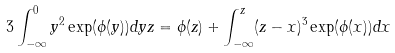Convert formula to latex. <formula><loc_0><loc_0><loc_500><loc_500>3 \int _ { - \infty } ^ { 0 } y ^ { 2 } \exp ( \phi ( y ) ) d y z = \phi ( z ) + \int _ { - \infty } ^ { z } ( z - x ) ^ { 3 } \exp ( \phi ( x ) ) d x</formula> 